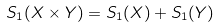Convert formula to latex. <formula><loc_0><loc_0><loc_500><loc_500>S _ { 1 } ( X \times Y ) = S _ { 1 } ( X ) + S _ { 1 } ( Y )</formula> 